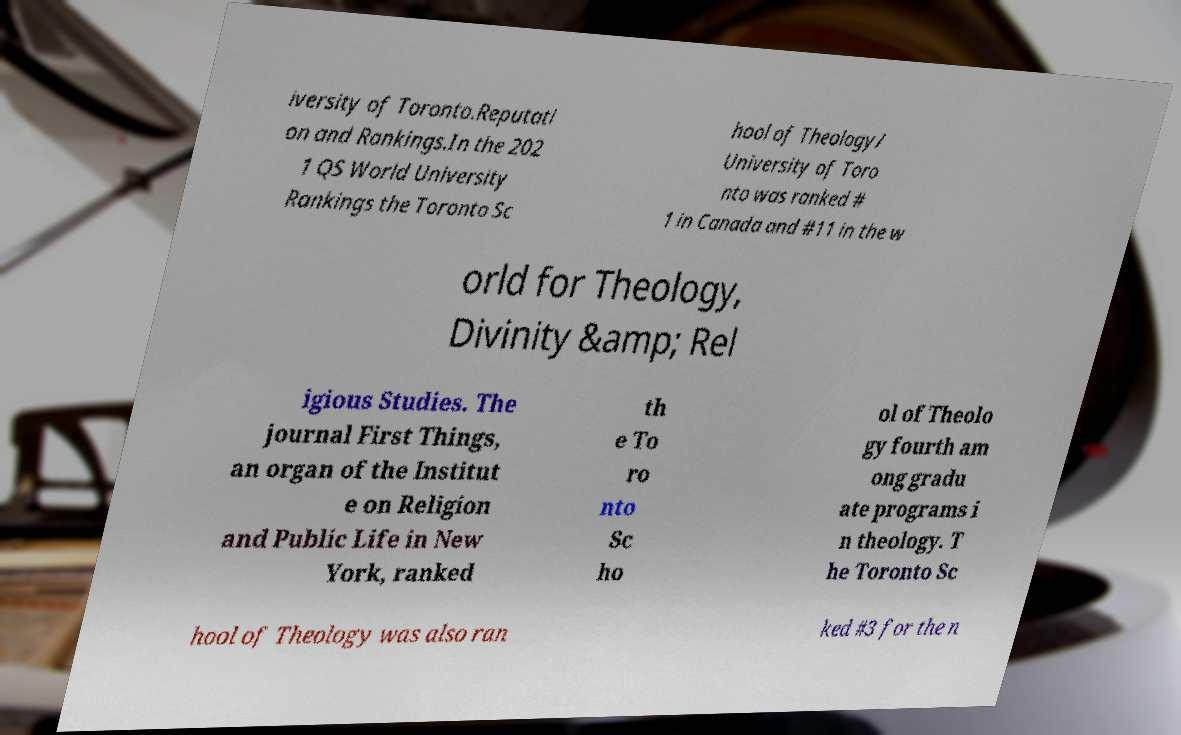I need the written content from this picture converted into text. Can you do that? iversity of Toronto.Reputati on and Rankings.In the 202 1 QS World University Rankings the Toronto Sc hool of Theology/ University of Toro nto was ranked # 1 in Canada and #11 in the w orld for Theology, Divinity &amp; Rel igious Studies. The journal First Things, an organ of the Institut e on Religion and Public Life in New York, ranked th e To ro nto Sc ho ol of Theolo gy fourth am ong gradu ate programs i n theology. T he Toronto Sc hool of Theology was also ran ked #3 for the n 